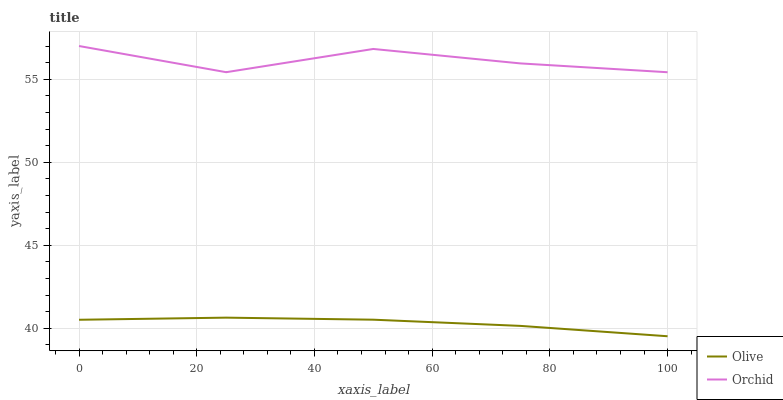Does Olive have the minimum area under the curve?
Answer yes or no. Yes. Does Orchid have the maximum area under the curve?
Answer yes or no. Yes. Does Orchid have the minimum area under the curve?
Answer yes or no. No. Is Olive the smoothest?
Answer yes or no. Yes. Is Orchid the roughest?
Answer yes or no. Yes. Is Orchid the smoothest?
Answer yes or no. No. Does Olive have the lowest value?
Answer yes or no. Yes. Does Orchid have the lowest value?
Answer yes or no. No. Does Orchid have the highest value?
Answer yes or no. Yes. Is Olive less than Orchid?
Answer yes or no. Yes. Is Orchid greater than Olive?
Answer yes or no. Yes. Does Olive intersect Orchid?
Answer yes or no. No. 